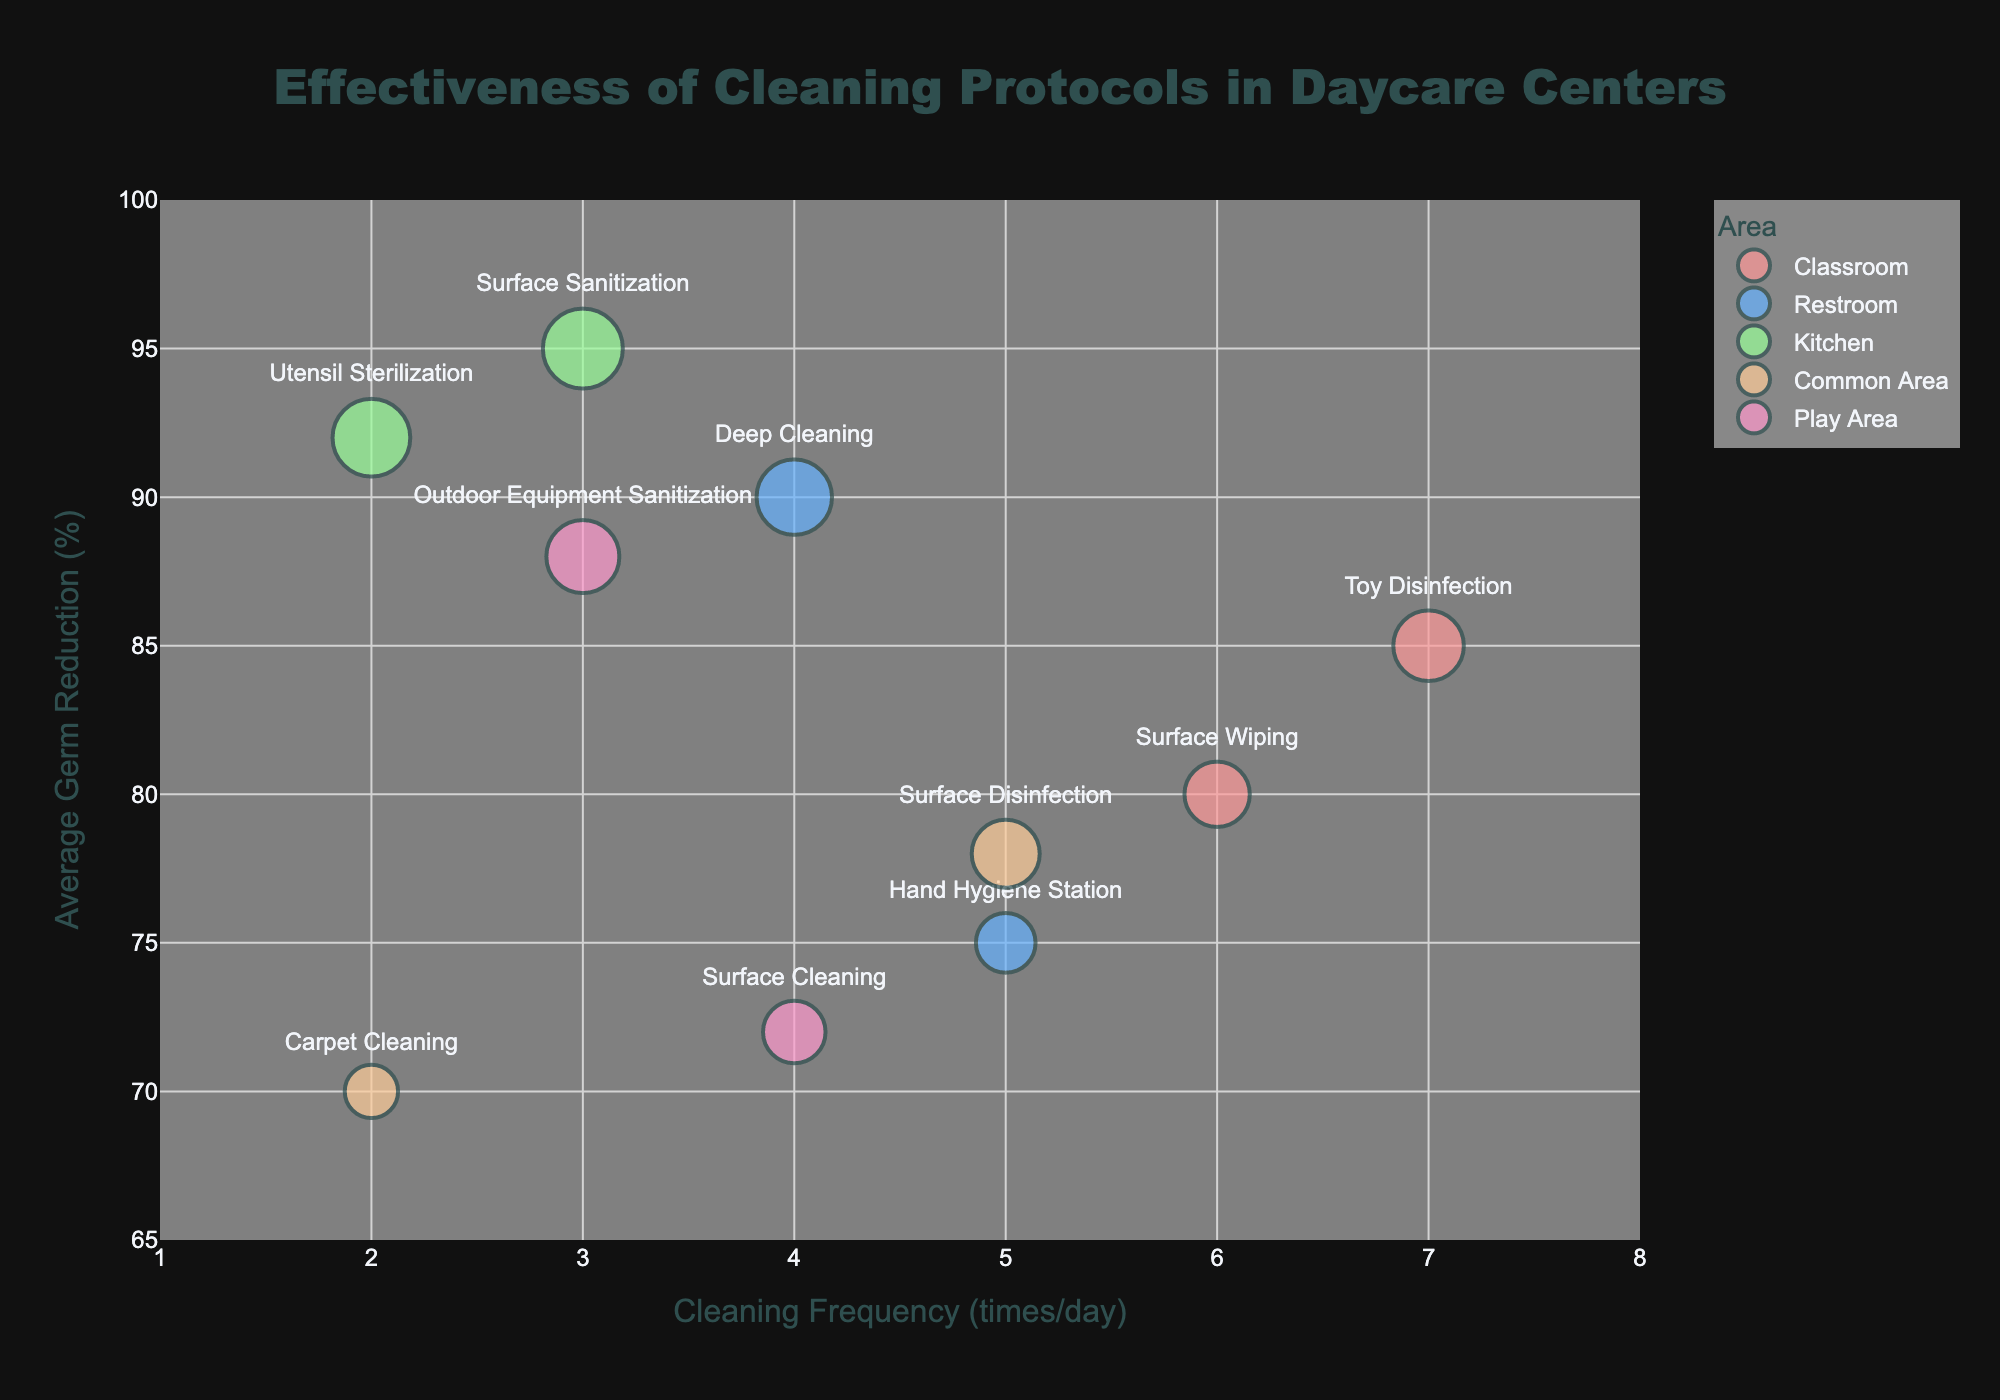What's the title of the figure? The title is typically displayed at the top of the figure. In this figure, it is clearly stated in the layout at the top center.
Answer: Effectiveness of Cleaning Protocols in Daycare Centers How many different areas are evaluated in this figure? By looking at the legend, we can see the distinct areas represented by different colors and names.
Answer: 5 Which cleaning protocol has the highest frequency of cleaning? By examining the x-axis values, we see that "Toy Disinfection" in the Classroom has the highest frequency of cleaning at 7 times/day.
Answer: Toy Disinfection What is the average percentage of germ reduction for the Kitchen area? Identify the Kitchen protocols on the chart, note their germ reduction values (95% for Surface Sanitization and 92% for Utensil Sterilization). Average them: (95 + 92) / 2.
Answer: 93.5% Which area has the largest bubble with the highest germ reduction? Locate the bubbles and compare their sizes and germ reduction percentages. The largest bubble in the Kitchen area for "Surface Sanitization" with a 95% reduction is the answer.
Answer: Kitchen, Surface Sanitization How does the frequency of cleaning correlate with the germ reduction percentages overall? Examine whether an increase in cleaning frequency typically results in a higher germ reduction percentage by comparing the plotted points. There is a general positive correlation: higher cleaning frequencies often correspond to higher germ reduction.
Answer: Positive correlation Which cleaning protocol in the Play Area has a higher effectiveness in germ reduction? Compare germ reduction percentages in the Play Area. "Outdoor Equipment Sanitization" has 88%, while "Surface Cleaning" has 72%.
Answer: Outdoor Equipment Sanitization What's the difference in germ reduction percentages between "Surface Disinfection" in the Common Area and "Deep Cleaning" in the Restroom? Calculate the difference by subtracting germ reduction percentages: 90% (Deep Cleaning) - 78% (Surface Disinfection).
Answer: 12% Which area has the protocol with the lowest germ reduction percentage and what is that percentage? Find the smallest y-value (representing germ reduction) and determine the corresponding area and protocol. "Carpet Cleaning" in the Common Area has the lowest germ reduction at 70%.
Answer: Common Area, Carpet Cleaning, 70% If a new protocol in the Classroom has the same germ reduction as "Toy Disinfection" but is done 4 times/day, where would it be plotted? Since "Toy Disinfection" has an 85% germ reduction, the new bubble would be plotted at (4, 85) on the chart.
Answer: (4, 85) 